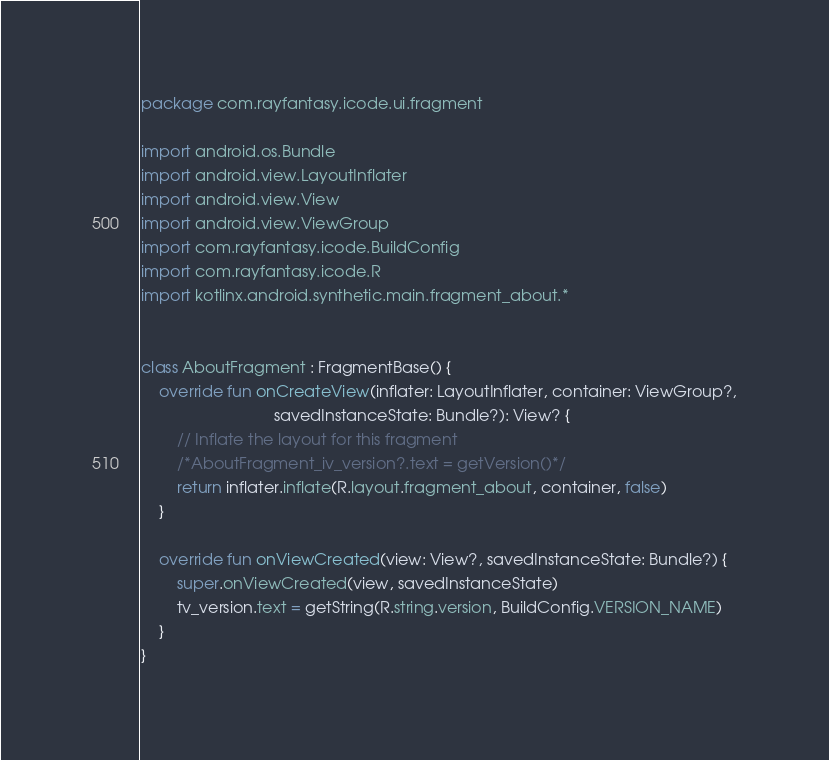Convert code to text. <code><loc_0><loc_0><loc_500><loc_500><_Kotlin_>package com.rayfantasy.icode.ui.fragment

import android.os.Bundle
import android.view.LayoutInflater
import android.view.View
import android.view.ViewGroup
import com.rayfantasy.icode.BuildConfig
import com.rayfantasy.icode.R
import kotlinx.android.synthetic.main.fragment_about.*


class AboutFragment : FragmentBase() {
    override fun onCreateView(inflater: LayoutInflater, container: ViewGroup?,
                              savedInstanceState: Bundle?): View? {
        // Inflate the layout for this fragment
        /*AboutFragment_iv_version?.text = getVersion()*/
        return inflater.inflate(R.layout.fragment_about, container, false)
    }

    override fun onViewCreated(view: View?, savedInstanceState: Bundle?) {
        super.onViewCreated(view, savedInstanceState)
        tv_version.text = getString(R.string.version, BuildConfig.VERSION_NAME)
    }
}
</code> 